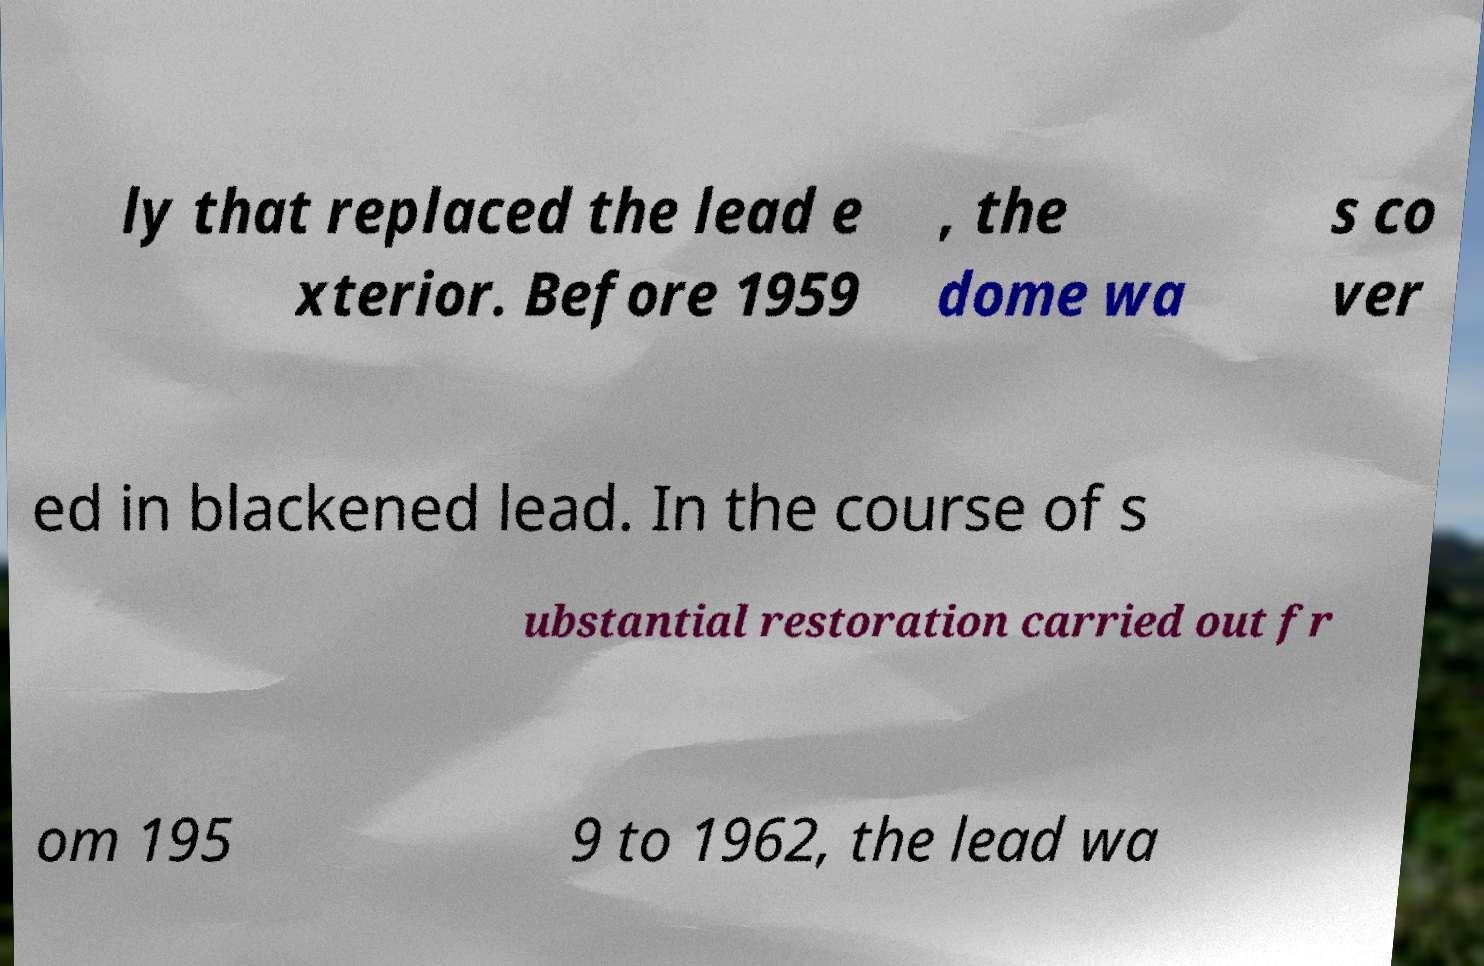There's text embedded in this image that I need extracted. Can you transcribe it verbatim? ly that replaced the lead e xterior. Before 1959 , the dome wa s co ver ed in blackened lead. In the course of s ubstantial restoration carried out fr om 195 9 to 1962, the lead wa 